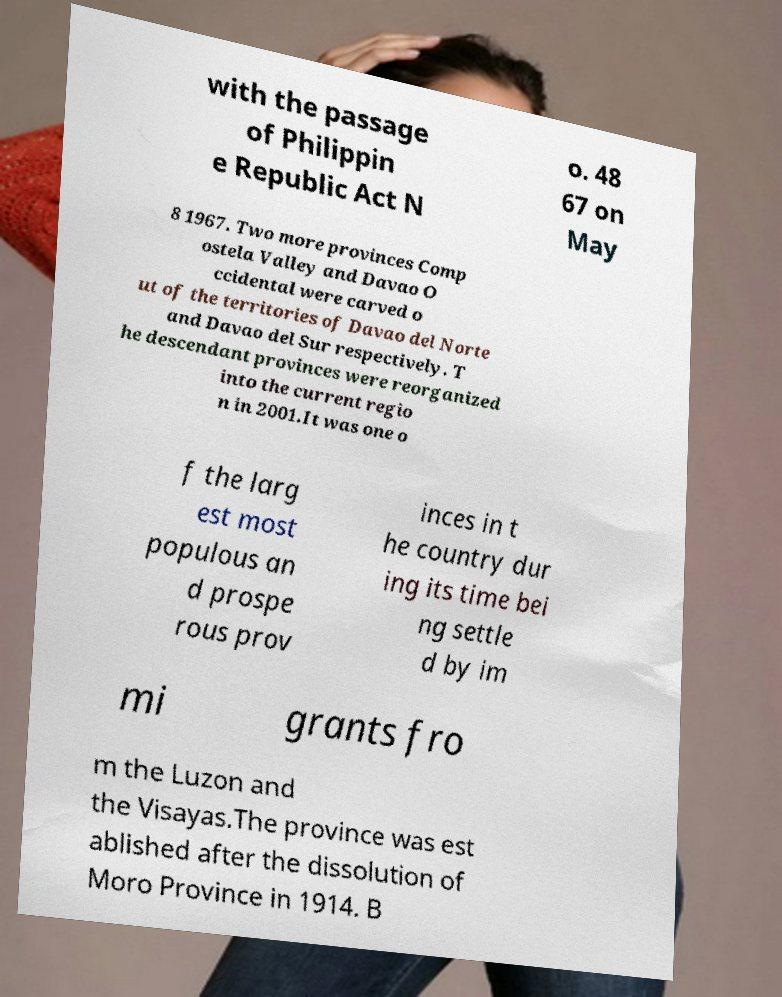Can you read and provide the text displayed in the image?This photo seems to have some interesting text. Can you extract and type it out for me? with the passage of Philippin e Republic Act N o. 48 67 on May 8 1967. Two more provinces Comp ostela Valley and Davao O ccidental were carved o ut of the territories of Davao del Norte and Davao del Sur respectively. T he descendant provinces were reorganized into the current regio n in 2001.It was one o f the larg est most populous an d prospe rous prov inces in t he country dur ing its time bei ng settle d by im mi grants fro m the Luzon and the Visayas.The province was est ablished after the dissolution of Moro Province in 1914. B 